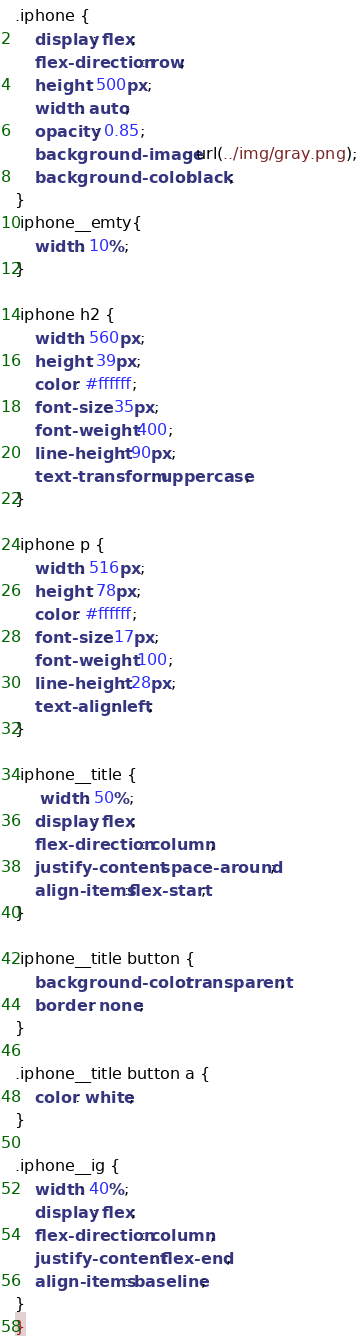Convert code to text. <code><loc_0><loc_0><loc_500><loc_500><_CSS_>.iphone {
    display: flex;
    flex-direction: row;
    height: 500px;
    width: auto;
    opacity: 0.85;
    background-image: url(../img/gray.png);
    background-color: black;
}
.iphone__emty{
    width: 10%;
}

.iphone h2 {
    width: 560px;
    height: 39px;
    color: #ffffff;
    font-size: 35px;
    font-weight: 400;
    line-height: 90px;
    text-transform: uppercase;
}

.iphone p {
    width: 516px;
    height: 78px;
    color: #ffffff;
    font-size: 17px;
    font-weight: 100;
    line-height: 28px;
    text-align: left;
}

.iphone__title {
     width: 50%;
    display: flex;
    flex-direction: column;
    justify-content: space-around;
    align-items:flex-start;
}

.iphone__title button {
    background-color: transparent;
    border: none;
}

.iphone__title button a {
    color: white;
}

.iphone__ig {
    width: 40%;
    display: flex;
    flex-direction: column;
    justify-content: flex-end;
    align-items: baseline;
}
}
</code> 